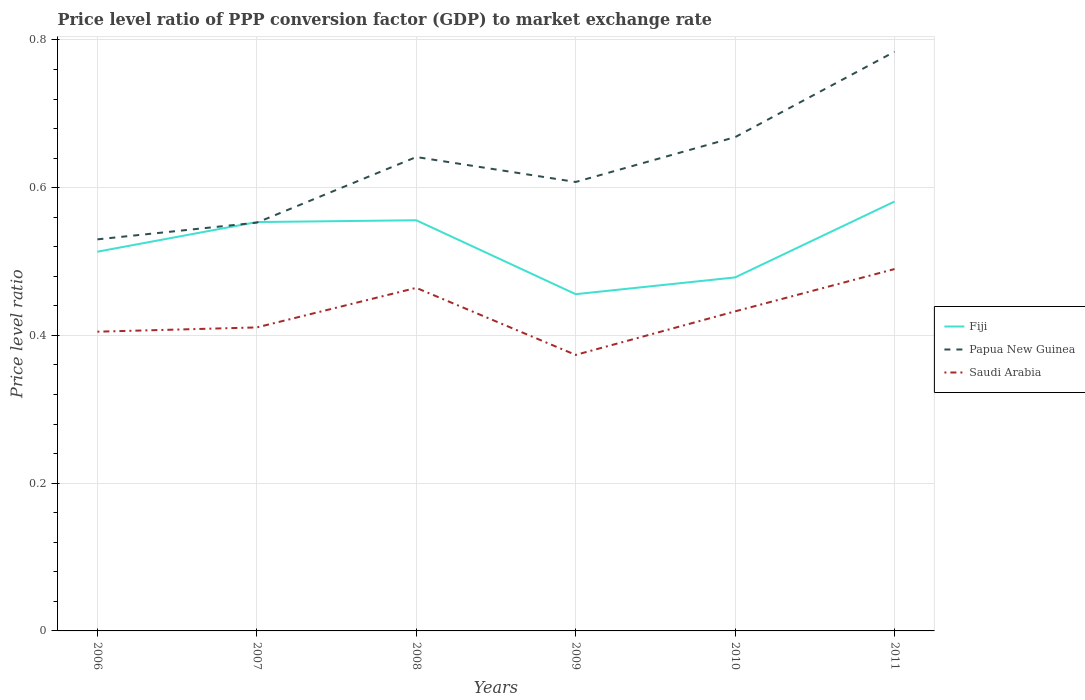Does the line corresponding to Papua New Guinea intersect with the line corresponding to Fiji?
Give a very brief answer. Yes. Is the number of lines equal to the number of legend labels?
Offer a terse response. Yes. Across all years, what is the maximum price level ratio in Saudi Arabia?
Give a very brief answer. 0.37. What is the total price level ratio in Saudi Arabia in the graph?
Your answer should be compact. -0.06. What is the difference between the highest and the second highest price level ratio in Papua New Guinea?
Offer a terse response. 0.25. What is the difference between two consecutive major ticks on the Y-axis?
Offer a terse response. 0.2. Are the values on the major ticks of Y-axis written in scientific E-notation?
Keep it short and to the point. No. Does the graph contain any zero values?
Offer a very short reply. No. Does the graph contain grids?
Your answer should be compact. Yes. Where does the legend appear in the graph?
Your answer should be compact. Center right. How are the legend labels stacked?
Your response must be concise. Vertical. What is the title of the graph?
Offer a terse response. Price level ratio of PPP conversion factor (GDP) to market exchange rate. What is the label or title of the Y-axis?
Your answer should be compact. Price level ratio. What is the Price level ratio in Fiji in 2006?
Make the answer very short. 0.51. What is the Price level ratio of Papua New Guinea in 2006?
Offer a terse response. 0.53. What is the Price level ratio of Saudi Arabia in 2006?
Provide a short and direct response. 0.41. What is the Price level ratio of Fiji in 2007?
Your answer should be very brief. 0.55. What is the Price level ratio in Papua New Guinea in 2007?
Keep it short and to the point. 0.55. What is the Price level ratio of Saudi Arabia in 2007?
Provide a short and direct response. 0.41. What is the Price level ratio in Fiji in 2008?
Offer a terse response. 0.56. What is the Price level ratio of Papua New Guinea in 2008?
Your answer should be very brief. 0.64. What is the Price level ratio in Saudi Arabia in 2008?
Offer a very short reply. 0.46. What is the Price level ratio in Fiji in 2009?
Your response must be concise. 0.46. What is the Price level ratio in Papua New Guinea in 2009?
Offer a very short reply. 0.61. What is the Price level ratio of Saudi Arabia in 2009?
Keep it short and to the point. 0.37. What is the Price level ratio in Fiji in 2010?
Offer a terse response. 0.48. What is the Price level ratio in Papua New Guinea in 2010?
Make the answer very short. 0.67. What is the Price level ratio in Saudi Arabia in 2010?
Your answer should be very brief. 0.43. What is the Price level ratio of Fiji in 2011?
Your response must be concise. 0.58. What is the Price level ratio of Papua New Guinea in 2011?
Keep it short and to the point. 0.78. What is the Price level ratio in Saudi Arabia in 2011?
Give a very brief answer. 0.49. Across all years, what is the maximum Price level ratio in Fiji?
Your answer should be very brief. 0.58. Across all years, what is the maximum Price level ratio in Papua New Guinea?
Make the answer very short. 0.78. Across all years, what is the maximum Price level ratio in Saudi Arabia?
Offer a very short reply. 0.49. Across all years, what is the minimum Price level ratio of Fiji?
Keep it short and to the point. 0.46. Across all years, what is the minimum Price level ratio of Papua New Guinea?
Give a very brief answer. 0.53. Across all years, what is the minimum Price level ratio in Saudi Arabia?
Provide a short and direct response. 0.37. What is the total Price level ratio in Fiji in the graph?
Provide a short and direct response. 3.14. What is the total Price level ratio in Papua New Guinea in the graph?
Offer a terse response. 3.78. What is the total Price level ratio of Saudi Arabia in the graph?
Make the answer very short. 2.58. What is the difference between the Price level ratio in Fiji in 2006 and that in 2007?
Your answer should be very brief. -0.04. What is the difference between the Price level ratio of Papua New Guinea in 2006 and that in 2007?
Provide a succinct answer. -0.02. What is the difference between the Price level ratio of Saudi Arabia in 2006 and that in 2007?
Provide a succinct answer. -0.01. What is the difference between the Price level ratio in Fiji in 2006 and that in 2008?
Provide a short and direct response. -0.04. What is the difference between the Price level ratio of Papua New Guinea in 2006 and that in 2008?
Your answer should be very brief. -0.11. What is the difference between the Price level ratio in Saudi Arabia in 2006 and that in 2008?
Ensure brevity in your answer.  -0.06. What is the difference between the Price level ratio in Fiji in 2006 and that in 2009?
Provide a succinct answer. 0.06. What is the difference between the Price level ratio in Papua New Guinea in 2006 and that in 2009?
Give a very brief answer. -0.08. What is the difference between the Price level ratio of Saudi Arabia in 2006 and that in 2009?
Offer a terse response. 0.03. What is the difference between the Price level ratio in Fiji in 2006 and that in 2010?
Provide a short and direct response. 0.03. What is the difference between the Price level ratio in Papua New Guinea in 2006 and that in 2010?
Offer a terse response. -0.14. What is the difference between the Price level ratio of Saudi Arabia in 2006 and that in 2010?
Ensure brevity in your answer.  -0.03. What is the difference between the Price level ratio of Fiji in 2006 and that in 2011?
Provide a short and direct response. -0.07. What is the difference between the Price level ratio in Papua New Guinea in 2006 and that in 2011?
Provide a succinct answer. -0.25. What is the difference between the Price level ratio of Saudi Arabia in 2006 and that in 2011?
Your answer should be compact. -0.08. What is the difference between the Price level ratio of Fiji in 2007 and that in 2008?
Keep it short and to the point. -0. What is the difference between the Price level ratio in Papua New Guinea in 2007 and that in 2008?
Keep it short and to the point. -0.09. What is the difference between the Price level ratio in Saudi Arabia in 2007 and that in 2008?
Make the answer very short. -0.05. What is the difference between the Price level ratio in Fiji in 2007 and that in 2009?
Offer a very short reply. 0.1. What is the difference between the Price level ratio in Papua New Guinea in 2007 and that in 2009?
Your answer should be compact. -0.06. What is the difference between the Price level ratio in Saudi Arabia in 2007 and that in 2009?
Offer a very short reply. 0.04. What is the difference between the Price level ratio of Fiji in 2007 and that in 2010?
Your answer should be compact. 0.07. What is the difference between the Price level ratio in Papua New Guinea in 2007 and that in 2010?
Ensure brevity in your answer.  -0.12. What is the difference between the Price level ratio in Saudi Arabia in 2007 and that in 2010?
Your answer should be very brief. -0.02. What is the difference between the Price level ratio in Fiji in 2007 and that in 2011?
Offer a terse response. -0.03. What is the difference between the Price level ratio of Papua New Guinea in 2007 and that in 2011?
Ensure brevity in your answer.  -0.23. What is the difference between the Price level ratio of Saudi Arabia in 2007 and that in 2011?
Offer a very short reply. -0.08. What is the difference between the Price level ratio of Fiji in 2008 and that in 2009?
Provide a short and direct response. 0.1. What is the difference between the Price level ratio of Papua New Guinea in 2008 and that in 2009?
Offer a terse response. 0.03. What is the difference between the Price level ratio in Saudi Arabia in 2008 and that in 2009?
Ensure brevity in your answer.  0.09. What is the difference between the Price level ratio in Fiji in 2008 and that in 2010?
Your answer should be compact. 0.08. What is the difference between the Price level ratio in Papua New Guinea in 2008 and that in 2010?
Offer a very short reply. -0.03. What is the difference between the Price level ratio of Saudi Arabia in 2008 and that in 2010?
Your response must be concise. 0.03. What is the difference between the Price level ratio in Fiji in 2008 and that in 2011?
Your response must be concise. -0.03. What is the difference between the Price level ratio in Papua New Guinea in 2008 and that in 2011?
Keep it short and to the point. -0.14. What is the difference between the Price level ratio in Saudi Arabia in 2008 and that in 2011?
Provide a succinct answer. -0.03. What is the difference between the Price level ratio in Fiji in 2009 and that in 2010?
Your answer should be very brief. -0.02. What is the difference between the Price level ratio of Papua New Guinea in 2009 and that in 2010?
Your answer should be compact. -0.06. What is the difference between the Price level ratio in Saudi Arabia in 2009 and that in 2010?
Offer a very short reply. -0.06. What is the difference between the Price level ratio in Fiji in 2009 and that in 2011?
Offer a very short reply. -0.13. What is the difference between the Price level ratio of Papua New Guinea in 2009 and that in 2011?
Keep it short and to the point. -0.18. What is the difference between the Price level ratio of Saudi Arabia in 2009 and that in 2011?
Keep it short and to the point. -0.12. What is the difference between the Price level ratio in Fiji in 2010 and that in 2011?
Ensure brevity in your answer.  -0.1. What is the difference between the Price level ratio in Papua New Guinea in 2010 and that in 2011?
Provide a succinct answer. -0.12. What is the difference between the Price level ratio of Saudi Arabia in 2010 and that in 2011?
Keep it short and to the point. -0.06. What is the difference between the Price level ratio of Fiji in 2006 and the Price level ratio of Papua New Guinea in 2007?
Offer a terse response. -0.04. What is the difference between the Price level ratio of Fiji in 2006 and the Price level ratio of Saudi Arabia in 2007?
Offer a very short reply. 0.1. What is the difference between the Price level ratio of Papua New Guinea in 2006 and the Price level ratio of Saudi Arabia in 2007?
Offer a very short reply. 0.12. What is the difference between the Price level ratio of Fiji in 2006 and the Price level ratio of Papua New Guinea in 2008?
Keep it short and to the point. -0.13. What is the difference between the Price level ratio of Fiji in 2006 and the Price level ratio of Saudi Arabia in 2008?
Give a very brief answer. 0.05. What is the difference between the Price level ratio in Papua New Guinea in 2006 and the Price level ratio in Saudi Arabia in 2008?
Keep it short and to the point. 0.07. What is the difference between the Price level ratio of Fiji in 2006 and the Price level ratio of Papua New Guinea in 2009?
Give a very brief answer. -0.09. What is the difference between the Price level ratio in Fiji in 2006 and the Price level ratio in Saudi Arabia in 2009?
Provide a succinct answer. 0.14. What is the difference between the Price level ratio of Papua New Guinea in 2006 and the Price level ratio of Saudi Arabia in 2009?
Give a very brief answer. 0.16. What is the difference between the Price level ratio in Fiji in 2006 and the Price level ratio in Papua New Guinea in 2010?
Provide a succinct answer. -0.16. What is the difference between the Price level ratio of Fiji in 2006 and the Price level ratio of Saudi Arabia in 2010?
Your answer should be compact. 0.08. What is the difference between the Price level ratio of Papua New Guinea in 2006 and the Price level ratio of Saudi Arabia in 2010?
Provide a succinct answer. 0.1. What is the difference between the Price level ratio in Fiji in 2006 and the Price level ratio in Papua New Guinea in 2011?
Your answer should be compact. -0.27. What is the difference between the Price level ratio of Fiji in 2006 and the Price level ratio of Saudi Arabia in 2011?
Ensure brevity in your answer.  0.02. What is the difference between the Price level ratio of Papua New Guinea in 2006 and the Price level ratio of Saudi Arabia in 2011?
Your answer should be very brief. 0.04. What is the difference between the Price level ratio of Fiji in 2007 and the Price level ratio of Papua New Guinea in 2008?
Offer a terse response. -0.09. What is the difference between the Price level ratio of Fiji in 2007 and the Price level ratio of Saudi Arabia in 2008?
Give a very brief answer. 0.09. What is the difference between the Price level ratio in Papua New Guinea in 2007 and the Price level ratio in Saudi Arabia in 2008?
Your response must be concise. 0.09. What is the difference between the Price level ratio in Fiji in 2007 and the Price level ratio in Papua New Guinea in 2009?
Offer a very short reply. -0.05. What is the difference between the Price level ratio in Fiji in 2007 and the Price level ratio in Saudi Arabia in 2009?
Your answer should be very brief. 0.18. What is the difference between the Price level ratio in Papua New Guinea in 2007 and the Price level ratio in Saudi Arabia in 2009?
Your response must be concise. 0.18. What is the difference between the Price level ratio of Fiji in 2007 and the Price level ratio of Papua New Guinea in 2010?
Your answer should be very brief. -0.12. What is the difference between the Price level ratio in Fiji in 2007 and the Price level ratio in Saudi Arabia in 2010?
Keep it short and to the point. 0.12. What is the difference between the Price level ratio of Papua New Guinea in 2007 and the Price level ratio of Saudi Arabia in 2010?
Your response must be concise. 0.12. What is the difference between the Price level ratio of Fiji in 2007 and the Price level ratio of Papua New Guinea in 2011?
Ensure brevity in your answer.  -0.23. What is the difference between the Price level ratio of Fiji in 2007 and the Price level ratio of Saudi Arabia in 2011?
Your answer should be very brief. 0.06. What is the difference between the Price level ratio of Papua New Guinea in 2007 and the Price level ratio of Saudi Arabia in 2011?
Your response must be concise. 0.06. What is the difference between the Price level ratio of Fiji in 2008 and the Price level ratio of Papua New Guinea in 2009?
Provide a succinct answer. -0.05. What is the difference between the Price level ratio in Fiji in 2008 and the Price level ratio in Saudi Arabia in 2009?
Provide a succinct answer. 0.18. What is the difference between the Price level ratio of Papua New Guinea in 2008 and the Price level ratio of Saudi Arabia in 2009?
Offer a terse response. 0.27. What is the difference between the Price level ratio of Fiji in 2008 and the Price level ratio of Papua New Guinea in 2010?
Your answer should be compact. -0.11. What is the difference between the Price level ratio in Fiji in 2008 and the Price level ratio in Saudi Arabia in 2010?
Give a very brief answer. 0.12. What is the difference between the Price level ratio in Papua New Guinea in 2008 and the Price level ratio in Saudi Arabia in 2010?
Ensure brevity in your answer.  0.21. What is the difference between the Price level ratio of Fiji in 2008 and the Price level ratio of Papua New Guinea in 2011?
Your answer should be very brief. -0.23. What is the difference between the Price level ratio of Fiji in 2008 and the Price level ratio of Saudi Arabia in 2011?
Offer a very short reply. 0.07. What is the difference between the Price level ratio of Papua New Guinea in 2008 and the Price level ratio of Saudi Arabia in 2011?
Your response must be concise. 0.15. What is the difference between the Price level ratio of Fiji in 2009 and the Price level ratio of Papua New Guinea in 2010?
Provide a succinct answer. -0.21. What is the difference between the Price level ratio of Fiji in 2009 and the Price level ratio of Saudi Arabia in 2010?
Offer a terse response. 0.02. What is the difference between the Price level ratio of Papua New Guinea in 2009 and the Price level ratio of Saudi Arabia in 2010?
Keep it short and to the point. 0.18. What is the difference between the Price level ratio of Fiji in 2009 and the Price level ratio of Papua New Guinea in 2011?
Your answer should be very brief. -0.33. What is the difference between the Price level ratio in Fiji in 2009 and the Price level ratio in Saudi Arabia in 2011?
Offer a very short reply. -0.03. What is the difference between the Price level ratio in Papua New Guinea in 2009 and the Price level ratio in Saudi Arabia in 2011?
Your response must be concise. 0.12. What is the difference between the Price level ratio of Fiji in 2010 and the Price level ratio of Papua New Guinea in 2011?
Your answer should be very brief. -0.31. What is the difference between the Price level ratio in Fiji in 2010 and the Price level ratio in Saudi Arabia in 2011?
Your answer should be compact. -0.01. What is the difference between the Price level ratio of Papua New Guinea in 2010 and the Price level ratio of Saudi Arabia in 2011?
Keep it short and to the point. 0.18. What is the average Price level ratio of Fiji per year?
Offer a very short reply. 0.52. What is the average Price level ratio in Papua New Guinea per year?
Your response must be concise. 0.63. What is the average Price level ratio in Saudi Arabia per year?
Your answer should be compact. 0.43. In the year 2006, what is the difference between the Price level ratio in Fiji and Price level ratio in Papua New Guinea?
Offer a terse response. -0.02. In the year 2006, what is the difference between the Price level ratio in Fiji and Price level ratio in Saudi Arabia?
Keep it short and to the point. 0.11. In the year 2007, what is the difference between the Price level ratio of Fiji and Price level ratio of Papua New Guinea?
Provide a succinct answer. 0. In the year 2007, what is the difference between the Price level ratio in Fiji and Price level ratio in Saudi Arabia?
Your response must be concise. 0.14. In the year 2007, what is the difference between the Price level ratio in Papua New Guinea and Price level ratio in Saudi Arabia?
Make the answer very short. 0.14. In the year 2008, what is the difference between the Price level ratio in Fiji and Price level ratio in Papua New Guinea?
Your answer should be compact. -0.09. In the year 2008, what is the difference between the Price level ratio in Fiji and Price level ratio in Saudi Arabia?
Keep it short and to the point. 0.09. In the year 2008, what is the difference between the Price level ratio in Papua New Guinea and Price level ratio in Saudi Arabia?
Offer a very short reply. 0.18. In the year 2009, what is the difference between the Price level ratio in Fiji and Price level ratio in Papua New Guinea?
Offer a very short reply. -0.15. In the year 2009, what is the difference between the Price level ratio of Fiji and Price level ratio of Saudi Arabia?
Provide a short and direct response. 0.08. In the year 2009, what is the difference between the Price level ratio of Papua New Guinea and Price level ratio of Saudi Arabia?
Give a very brief answer. 0.23. In the year 2010, what is the difference between the Price level ratio of Fiji and Price level ratio of Papua New Guinea?
Give a very brief answer. -0.19. In the year 2010, what is the difference between the Price level ratio of Fiji and Price level ratio of Saudi Arabia?
Keep it short and to the point. 0.05. In the year 2010, what is the difference between the Price level ratio of Papua New Guinea and Price level ratio of Saudi Arabia?
Your answer should be very brief. 0.24. In the year 2011, what is the difference between the Price level ratio of Fiji and Price level ratio of Papua New Guinea?
Make the answer very short. -0.2. In the year 2011, what is the difference between the Price level ratio of Fiji and Price level ratio of Saudi Arabia?
Provide a short and direct response. 0.09. In the year 2011, what is the difference between the Price level ratio in Papua New Guinea and Price level ratio in Saudi Arabia?
Your answer should be compact. 0.29. What is the ratio of the Price level ratio in Fiji in 2006 to that in 2007?
Your answer should be compact. 0.93. What is the ratio of the Price level ratio of Saudi Arabia in 2006 to that in 2007?
Give a very brief answer. 0.99. What is the ratio of the Price level ratio in Fiji in 2006 to that in 2008?
Provide a succinct answer. 0.92. What is the ratio of the Price level ratio of Papua New Guinea in 2006 to that in 2008?
Provide a succinct answer. 0.83. What is the ratio of the Price level ratio in Saudi Arabia in 2006 to that in 2008?
Offer a terse response. 0.87. What is the ratio of the Price level ratio in Fiji in 2006 to that in 2009?
Your answer should be very brief. 1.13. What is the ratio of the Price level ratio of Papua New Guinea in 2006 to that in 2009?
Your answer should be compact. 0.87. What is the ratio of the Price level ratio of Saudi Arabia in 2006 to that in 2009?
Your response must be concise. 1.08. What is the ratio of the Price level ratio of Fiji in 2006 to that in 2010?
Ensure brevity in your answer.  1.07. What is the ratio of the Price level ratio of Papua New Guinea in 2006 to that in 2010?
Provide a succinct answer. 0.79. What is the ratio of the Price level ratio in Saudi Arabia in 2006 to that in 2010?
Give a very brief answer. 0.94. What is the ratio of the Price level ratio in Fiji in 2006 to that in 2011?
Keep it short and to the point. 0.88. What is the ratio of the Price level ratio of Papua New Guinea in 2006 to that in 2011?
Your answer should be very brief. 0.68. What is the ratio of the Price level ratio of Saudi Arabia in 2006 to that in 2011?
Keep it short and to the point. 0.83. What is the ratio of the Price level ratio of Fiji in 2007 to that in 2008?
Offer a terse response. 1. What is the ratio of the Price level ratio of Papua New Guinea in 2007 to that in 2008?
Give a very brief answer. 0.86. What is the ratio of the Price level ratio in Saudi Arabia in 2007 to that in 2008?
Your response must be concise. 0.88. What is the ratio of the Price level ratio in Fiji in 2007 to that in 2009?
Offer a very short reply. 1.21. What is the ratio of the Price level ratio in Papua New Guinea in 2007 to that in 2009?
Give a very brief answer. 0.91. What is the ratio of the Price level ratio in Saudi Arabia in 2007 to that in 2009?
Make the answer very short. 1.1. What is the ratio of the Price level ratio of Fiji in 2007 to that in 2010?
Your answer should be very brief. 1.16. What is the ratio of the Price level ratio in Papua New Guinea in 2007 to that in 2010?
Your answer should be very brief. 0.83. What is the ratio of the Price level ratio in Saudi Arabia in 2007 to that in 2010?
Your answer should be very brief. 0.95. What is the ratio of the Price level ratio of Fiji in 2007 to that in 2011?
Ensure brevity in your answer.  0.95. What is the ratio of the Price level ratio in Papua New Guinea in 2007 to that in 2011?
Offer a very short reply. 0.7. What is the ratio of the Price level ratio of Saudi Arabia in 2007 to that in 2011?
Ensure brevity in your answer.  0.84. What is the ratio of the Price level ratio in Fiji in 2008 to that in 2009?
Keep it short and to the point. 1.22. What is the ratio of the Price level ratio in Papua New Guinea in 2008 to that in 2009?
Keep it short and to the point. 1.06. What is the ratio of the Price level ratio of Saudi Arabia in 2008 to that in 2009?
Ensure brevity in your answer.  1.24. What is the ratio of the Price level ratio in Fiji in 2008 to that in 2010?
Provide a succinct answer. 1.16. What is the ratio of the Price level ratio of Papua New Guinea in 2008 to that in 2010?
Provide a succinct answer. 0.96. What is the ratio of the Price level ratio of Saudi Arabia in 2008 to that in 2010?
Give a very brief answer. 1.07. What is the ratio of the Price level ratio in Fiji in 2008 to that in 2011?
Offer a very short reply. 0.96. What is the ratio of the Price level ratio of Papua New Guinea in 2008 to that in 2011?
Keep it short and to the point. 0.82. What is the ratio of the Price level ratio in Saudi Arabia in 2008 to that in 2011?
Offer a terse response. 0.95. What is the ratio of the Price level ratio in Fiji in 2009 to that in 2010?
Your answer should be very brief. 0.95. What is the ratio of the Price level ratio of Papua New Guinea in 2009 to that in 2010?
Your answer should be compact. 0.91. What is the ratio of the Price level ratio of Saudi Arabia in 2009 to that in 2010?
Provide a short and direct response. 0.86. What is the ratio of the Price level ratio of Fiji in 2009 to that in 2011?
Ensure brevity in your answer.  0.78. What is the ratio of the Price level ratio in Papua New Guinea in 2009 to that in 2011?
Offer a terse response. 0.78. What is the ratio of the Price level ratio of Saudi Arabia in 2009 to that in 2011?
Your response must be concise. 0.76. What is the ratio of the Price level ratio of Fiji in 2010 to that in 2011?
Provide a succinct answer. 0.82. What is the ratio of the Price level ratio in Papua New Guinea in 2010 to that in 2011?
Make the answer very short. 0.85. What is the ratio of the Price level ratio in Saudi Arabia in 2010 to that in 2011?
Provide a succinct answer. 0.88. What is the difference between the highest and the second highest Price level ratio in Fiji?
Offer a very short reply. 0.03. What is the difference between the highest and the second highest Price level ratio in Papua New Guinea?
Offer a very short reply. 0.12. What is the difference between the highest and the second highest Price level ratio in Saudi Arabia?
Make the answer very short. 0.03. What is the difference between the highest and the lowest Price level ratio in Fiji?
Offer a very short reply. 0.13. What is the difference between the highest and the lowest Price level ratio in Papua New Guinea?
Give a very brief answer. 0.25. What is the difference between the highest and the lowest Price level ratio of Saudi Arabia?
Make the answer very short. 0.12. 